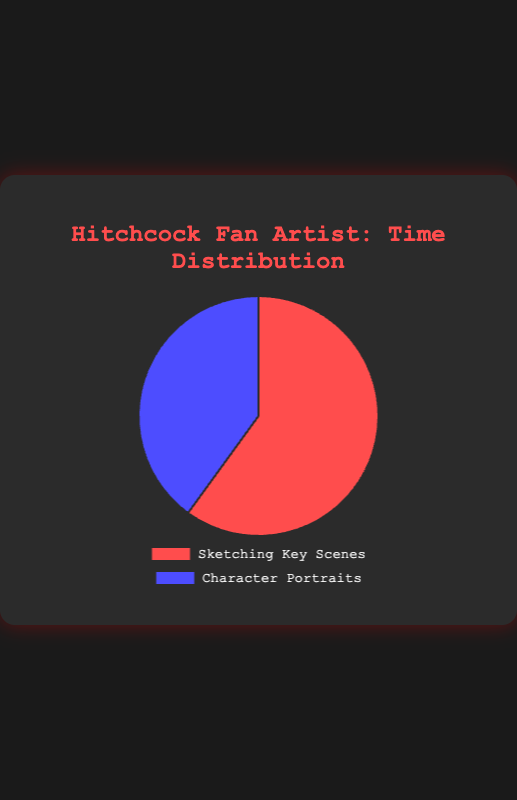How much more time is spent sketching key scenes compared to character portraits? The pie chart shows 60% for sketching key scenes and 40% for character portraits. The difference is 60% - 40% = 20%.
Answer: 20% Which activity has the higher proportion of time spent? By observing the pie chart, the 'Sketching Key Scenes' section is larger, representing 60% compared to the 'Character Portraits' section at 40%.
Answer: Sketching Key Scenes If you spent a total of 50 hours on your illustrations, how many hours were allocated to character portraits? 40% of 50 hours is calculated by (40/100) * 50 = 20 hours.
Answer: 20 hours What percentage of the total time is spent on sketching key scenes and character portraits combined? The total percentage in the pie chart must be 100% as it represents the entire distribution. So, 60% + 40% = 100%.
Answer: 100% If the time spent on each activity was doubled, what would be the new proportion of time spent sketching key scenes in percentage terms? If both activities double, their proportion remains the same because percentages are relative measures. Thus, the percentage remains 60%.
Answer: 60% Which color represents the character portraits section in the pie chart? The pie chart shows 'Character Portraits' in blue.
Answer: Blue If another activity was added, making the time spent on character portraits half of its original, what would be the new percentage for character portraits? If character portraits time is halved, the percentage contribution would be \( \frac{40}{2} = 20\% \).
Answer: 20% Between "The Birds" and "Rear Window", which film had more time spent on character portraits? "The Birds" had 15% of the time spent on character portraits compared to "Rear Window", which had 10%.
Answer: The Birds What is the ratio of time spent on sketching key scenes to character portraits based on the proportions in the pie chart? The ratio of 60% (key scenes) to 40% (portraits) simplifies to \( \frac{60}{40} = \frac{3}{2} \) or 3:2.
Answer: 3:2 Which activity is represented by the red section in the pie chart? The pie chart shows 'Sketching Key Scenes' represented by red.
Answer: Sketching Key Scenes 